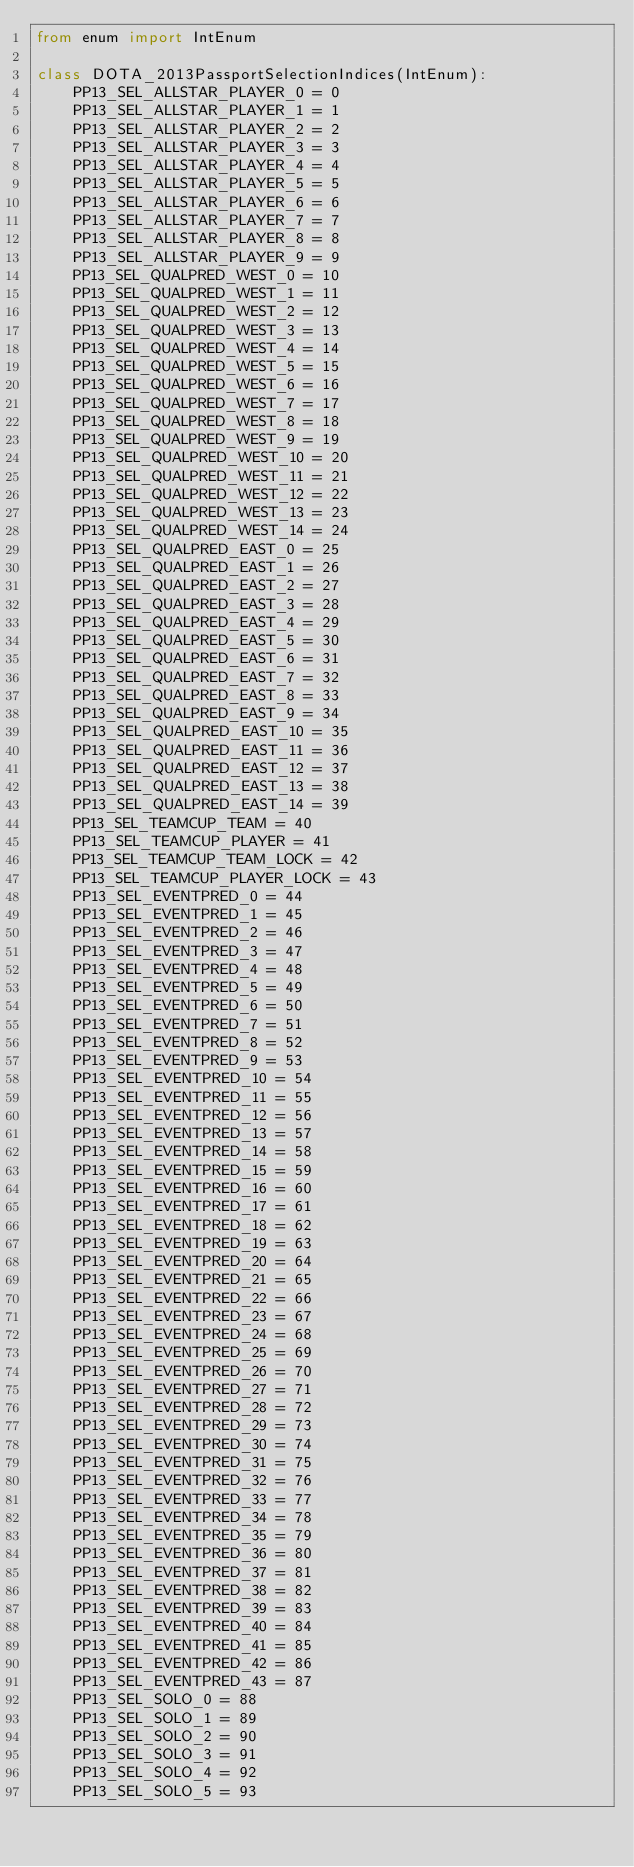<code> <loc_0><loc_0><loc_500><loc_500><_Python_>from enum import IntEnum

class DOTA_2013PassportSelectionIndices(IntEnum):
    PP13_SEL_ALLSTAR_PLAYER_0 = 0
    PP13_SEL_ALLSTAR_PLAYER_1 = 1
    PP13_SEL_ALLSTAR_PLAYER_2 = 2
    PP13_SEL_ALLSTAR_PLAYER_3 = 3
    PP13_SEL_ALLSTAR_PLAYER_4 = 4
    PP13_SEL_ALLSTAR_PLAYER_5 = 5
    PP13_SEL_ALLSTAR_PLAYER_6 = 6
    PP13_SEL_ALLSTAR_PLAYER_7 = 7
    PP13_SEL_ALLSTAR_PLAYER_8 = 8
    PP13_SEL_ALLSTAR_PLAYER_9 = 9
    PP13_SEL_QUALPRED_WEST_0 = 10
    PP13_SEL_QUALPRED_WEST_1 = 11
    PP13_SEL_QUALPRED_WEST_2 = 12
    PP13_SEL_QUALPRED_WEST_3 = 13
    PP13_SEL_QUALPRED_WEST_4 = 14
    PP13_SEL_QUALPRED_WEST_5 = 15
    PP13_SEL_QUALPRED_WEST_6 = 16
    PP13_SEL_QUALPRED_WEST_7 = 17
    PP13_SEL_QUALPRED_WEST_8 = 18
    PP13_SEL_QUALPRED_WEST_9 = 19
    PP13_SEL_QUALPRED_WEST_10 = 20
    PP13_SEL_QUALPRED_WEST_11 = 21
    PP13_SEL_QUALPRED_WEST_12 = 22
    PP13_SEL_QUALPRED_WEST_13 = 23
    PP13_SEL_QUALPRED_WEST_14 = 24
    PP13_SEL_QUALPRED_EAST_0 = 25
    PP13_SEL_QUALPRED_EAST_1 = 26
    PP13_SEL_QUALPRED_EAST_2 = 27
    PP13_SEL_QUALPRED_EAST_3 = 28
    PP13_SEL_QUALPRED_EAST_4 = 29
    PP13_SEL_QUALPRED_EAST_5 = 30
    PP13_SEL_QUALPRED_EAST_6 = 31
    PP13_SEL_QUALPRED_EAST_7 = 32
    PP13_SEL_QUALPRED_EAST_8 = 33
    PP13_SEL_QUALPRED_EAST_9 = 34
    PP13_SEL_QUALPRED_EAST_10 = 35
    PP13_SEL_QUALPRED_EAST_11 = 36
    PP13_SEL_QUALPRED_EAST_12 = 37
    PP13_SEL_QUALPRED_EAST_13 = 38
    PP13_SEL_QUALPRED_EAST_14 = 39
    PP13_SEL_TEAMCUP_TEAM = 40
    PP13_SEL_TEAMCUP_PLAYER = 41
    PP13_SEL_TEAMCUP_TEAM_LOCK = 42
    PP13_SEL_TEAMCUP_PLAYER_LOCK = 43
    PP13_SEL_EVENTPRED_0 = 44
    PP13_SEL_EVENTPRED_1 = 45
    PP13_SEL_EVENTPRED_2 = 46
    PP13_SEL_EVENTPRED_3 = 47
    PP13_SEL_EVENTPRED_4 = 48
    PP13_SEL_EVENTPRED_5 = 49
    PP13_SEL_EVENTPRED_6 = 50
    PP13_SEL_EVENTPRED_7 = 51
    PP13_SEL_EVENTPRED_8 = 52
    PP13_SEL_EVENTPRED_9 = 53
    PP13_SEL_EVENTPRED_10 = 54
    PP13_SEL_EVENTPRED_11 = 55
    PP13_SEL_EVENTPRED_12 = 56
    PP13_SEL_EVENTPRED_13 = 57
    PP13_SEL_EVENTPRED_14 = 58
    PP13_SEL_EVENTPRED_15 = 59
    PP13_SEL_EVENTPRED_16 = 60
    PP13_SEL_EVENTPRED_17 = 61
    PP13_SEL_EVENTPRED_18 = 62
    PP13_SEL_EVENTPRED_19 = 63
    PP13_SEL_EVENTPRED_20 = 64
    PP13_SEL_EVENTPRED_21 = 65
    PP13_SEL_EVENTPRED_22 = 66
    PP13_SEL_EVENTPRED_23 = 67
    PP13_SEL_EVENTPRED_24 = 68
    PP13_SEL_EVENTPRED_25 = 69
    PP13_SEL_EVENTPRED_26 = 70
    PP13_SEL_EVENTPRED_27 = 71
    PP13_SEL_EVENTPRED_28 = 72
    PP13_SEL_EVENTPRED_29 = 73
    PP13_SEL_EVENTPRED_30 = 74
    PP13_SEL_EVENTPRED_31 = 75
    PP13_SEL_EVENTPRED_32 = 76
    PP13_SEL_EVENTPRED_33 = 77
    PP13_SEL_EVENTPRED_34 = 78
    PP13_SEL_EVENTPRED_35 = 79
    PP13_SEL_EVENTPRED_36 = 80
    PP13_SEL_EVENTPRED_37 = 81
    PP13_SEL_EVENTPRED_38 = 82
    PP13_SEL_EVENTPRED_39 = 83
    PP13_SEL_EVENTPRED_40 = 84
    PP13_SEL_EVENTPRED_41 = 85
    PP13_SEL_EVENTPRED_42 = 86
    PP13_SEL_EVENTPRED_43 = 87
    PP13_SEL_SOLO_0 = 88
    PP13_SEL_SOLO_1 = 89
    PP13_SEL_SOLO_2 = 90
    PP13_SEL_SOLO_3 = 91
    PP13_SEL_SOLO_4 = 92
    PP13_SEL_SOLO_5 = 93</code> 